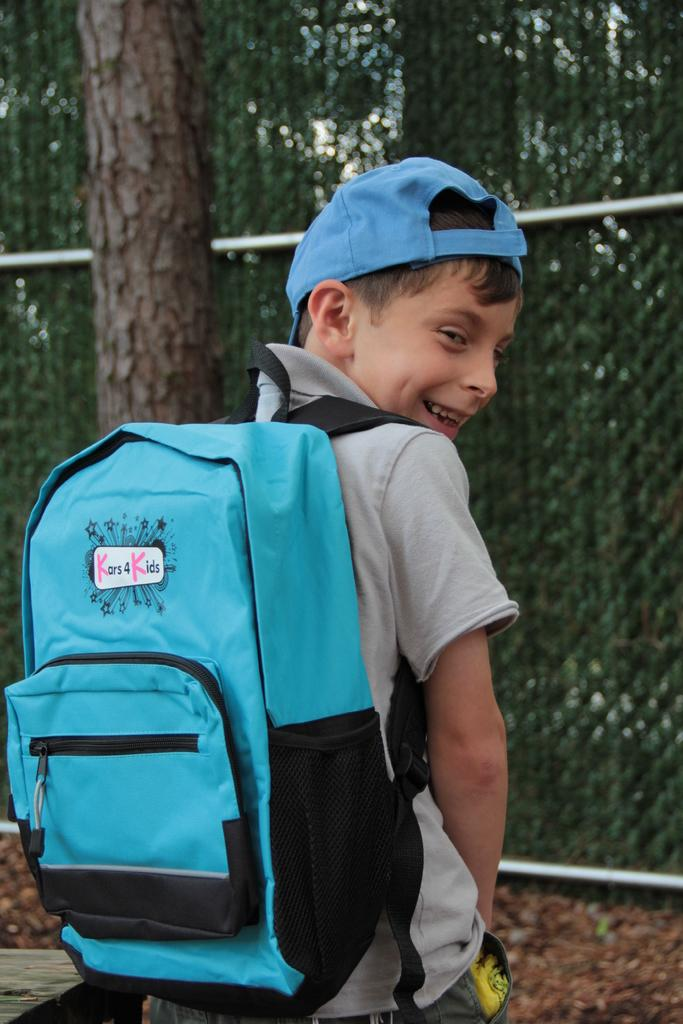<image>
Offer a succinct explanation of the picture presented. A child wears a blue backpack that has a Kars 4 Kids logo. 